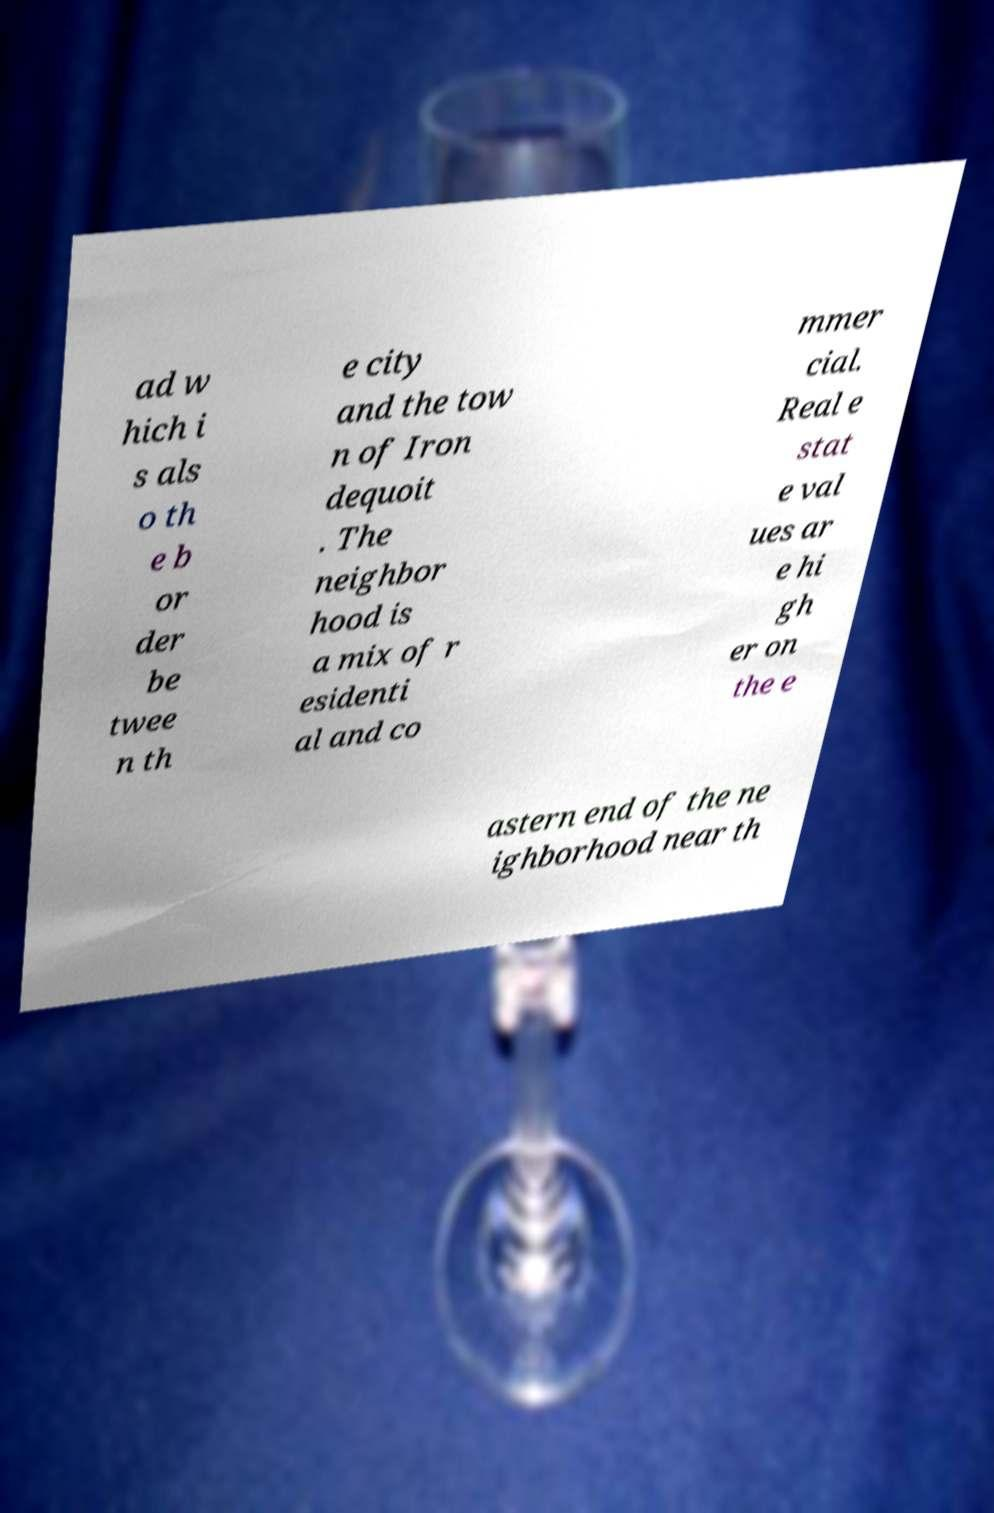Please read and relay the text visible in this image. What does it say? ad w hich i s als o th e b or der be twee n th e city and the tow n of Iron dequoit . The neighbor hood is a mix of r esidenti al and co mmer cial. Real e stat e val ues ar e hi gh er on the e astern end of the ne ighborhood near th 